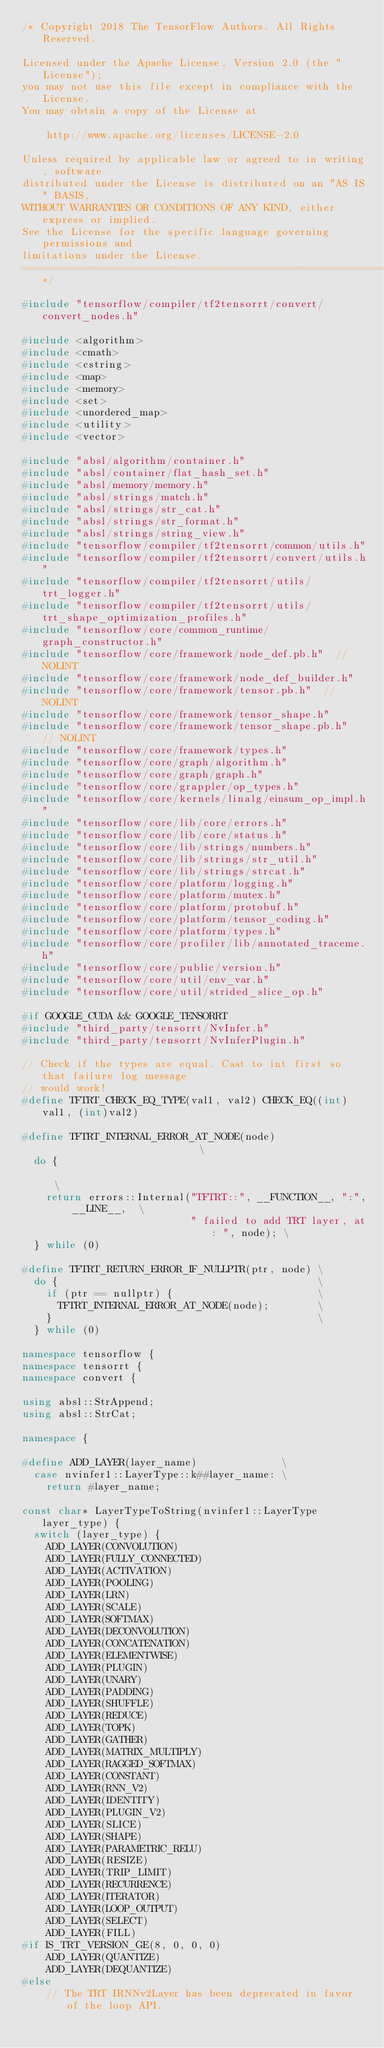<code> <loc_0><loc_0><loc_500><loc_500><_C++_>/* Copyright 2018 The TensorFlow Authors. All Rights Reserved.

Licensed under the Apache License, Version 2.0 (the "License");
you may not use this file except in compliance with the License.
You may obtain a copy of the License at

    http://www.apache.org/licenses/LICENSE-2.0

Unless required by applicable law or agreed to in writing, software
distributed under the License is distributed on an "AS IS" BASIS,
WITHOUT WARRANTIES OR CONDITIONS OF ANY KIND, either express or implied.
See the License for the specific language governing permissions and
limitations under the License.
==============================================================================*/

#include "tensorflow/compiler/tf2tensorrt/convert/convert_nodes.h"

#include <algorithm>
#include <cmath>
#include <cstring>
#include <map>
#include <memory>
#include <set>
#include <unordered_map>
#include <utility>
#include <vector>

#include "absl/algorithm/container.h"
#include "absl/container/flat_hash_set.h"
#include "absl/memory/memory.h"
#include "absl/strings/match.h"
#include "absl/strings/str_cat.h"
#include "absl/strings/str_format.h"
#include "absl/strings/string_view.h"
#include "tensorflow/compiler/tf2tensorrt/common/utils.h"
#include "tensorflow/compiler/tf2tensorrt/convert/utils.h"
#include "tensorflow/compiler/tf2tensorrt/utils/trt_logger.h"
#include "tensorflow/compiler/tf2tensorrt/utils/trt_shape_optimization_profiles.h"
#include "tensorflow/core/common_runtime/graph_constructor.h"
#include "tensorflow/core/framework/node_def.pb.h"  // NOLINT
#include "tensorflow/core/framework/node_def_builder.h"
#include "tensorflow/core/framework/tensor.pb.h"  // NOLINT
#include "tensorflow/core/framework/tensor_shape.h"
#include "tensorflow/core/framework/tensor_shape.pb.h"  // NOLINT
#include "tensorflow/core/framework/types.h"
#include "tensorflow/core/graph/algorithm.h"
#include "tensorflow/core/graph/graph.h"
#include "tensorflow/core/grappler/op_types.h"
#include "tensorflow/core/kernels/linalg/einsum_op_impl.h"
#include "tensorflow/core/lib/core/errors.h"
#include "tensorflow/core/lib/core/status.h"
#include "tensorflow/core/lib/strings/numbers.h"
#include "tensorflow/core/lib/strings/str_util.h"
#include "tensorflow/core/lib/strings/strcat.h"
#include "tensorflow/core/platform/logging.h"
#include "tensorflow/core/platform/mutex.h"
#include "tensorflow/core/platform/protobuf.h"
#include "tensorflow/core/platform/tensor_coding.h"
#include "tensorflow/core/platform/types.h"
#include "tensorflow/core/profiler/lib/annotated_traceme.h"
#include "tensorflow/core/public/version.h"
#include "tensorflow/core/util/env_var.h"
#include "tensorflow/core/util/strided_slice_op.h"

#if GOOGLE_CUDA && GOOGLE_TENSORRT
#include "third_party/tensorrt/NvInfer.h"
#include "third_party/tensorrt/NvInferPlugin.h"

// Check if the types are equal. Cast to int first so that failure log message
// would work!
#define TFTRT_CHECK_EQ_TYPE(val1, val2) CHECK_EQ((int)val1, (int)val2)

#define TFTRT_INTERNAL_ERROR_AT_NODE(node)                           \
  do {                                                               \
    return errors::Internal("TFTRT::", __FUNCTION__, ":", __LINE__,  \
                            " failed to add TRT layer, at: ", node); \
  } while (0)

#define TFTRT_RETURN_ERROR_IF_NULLPTR(ptr, node) \
  do {                                           \
    if (ptr == nullptr) {                        \
      TFTRT_INTERNAL_ERROR_AT_NODE(node);        \
    }                                            \
  } while (0)

namespace tensorflow {
namespace tensorrt {
namespace convert {

using absl::StrAppend;
using absl::StrCat;

namespace {

#define ADD_LAYER(layer_name)              \
  case nvinfer1::LayerType::k##layer_name: \
    return #layer_name;

const char* LayerTypeToString(nvinfer1::LayerType layer_type) {
  switch (layer_type) {
    ADD_LAYER(CONVOLUTION)
    ADD_LAYER(FULLY_CONNECTED)
    ADD_LAYER(ACTIVATION)
    ADD_LAYER(POOLING)
    ADD_LAYER(LRN)
    ADD_LAYER(SCALE)
    ADD_LAYER(SOFTMAX)
    ADD_LAYER(DECONVOLUTION)
    ADD_LAYER(CONCATENATION)
    ADD_LAYER(ELEMENTWISE)
    ADD_LAYER(PLUGIN)
    ADD_LAYER(UNARY)
    ADD_LAYER(PADDING)
    ADD_LAYER(SHUFFLE)
    ADD_LAYER(REDUCE)
    ADD_LAYER(TOPK)
    ADD_LAYER(GATHER)
    ADD_LAYER(MATRIX_MULTIPLY)
    ADD_LAYER(RAGGED_SOFTMAX)
    ADD_LAYER(CONSTANT)
    ADD_LAYER(RNN_V2)
    ADD_LAYER(IDENTITY)
    ADD_LAYER(PLUGIN_V2)
    ADD_LAYER(SLICE)
    ADD_LAYER(SHAPE)
    ADD_LAYER(PARAMETRIC_RELU)
    ADD_LAYER(RESIZE)
    ADD_LAYER(TRIP_LIMIT)
    ADD_LAYER(RECURRENCE)
    ADD_LAYER(ITERATOR)
    ADD_LAYER(LOOP_OUTPUT)
    ADD_LAYER(SELECT)
    ADD_LAYER(FILL)
#if IS_TRT_VERSION_GE(8, 0, 0, 0)
    ADD_LAYER(QUANTIZE)
    ADD_LAYER(DEQUANTIZE)
#else
    // The TRT IRNNv2Layer has been deprecated in favor of the loop API.</code> 